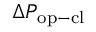Convert formula to latex. <formula><loc_0><loc_0><loc_500><loc_500>\Delta P _ { o p - c l }</formula> 